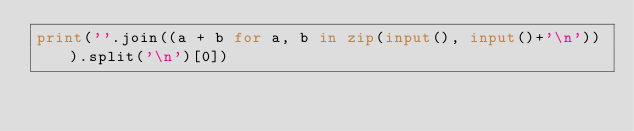<code> <loc_0><loc_0><loc_500><loc_500><_Python_>print(''.join((a + b for a, b in zip(input(), input()+'\n'))).split('\n')[0])</code> 